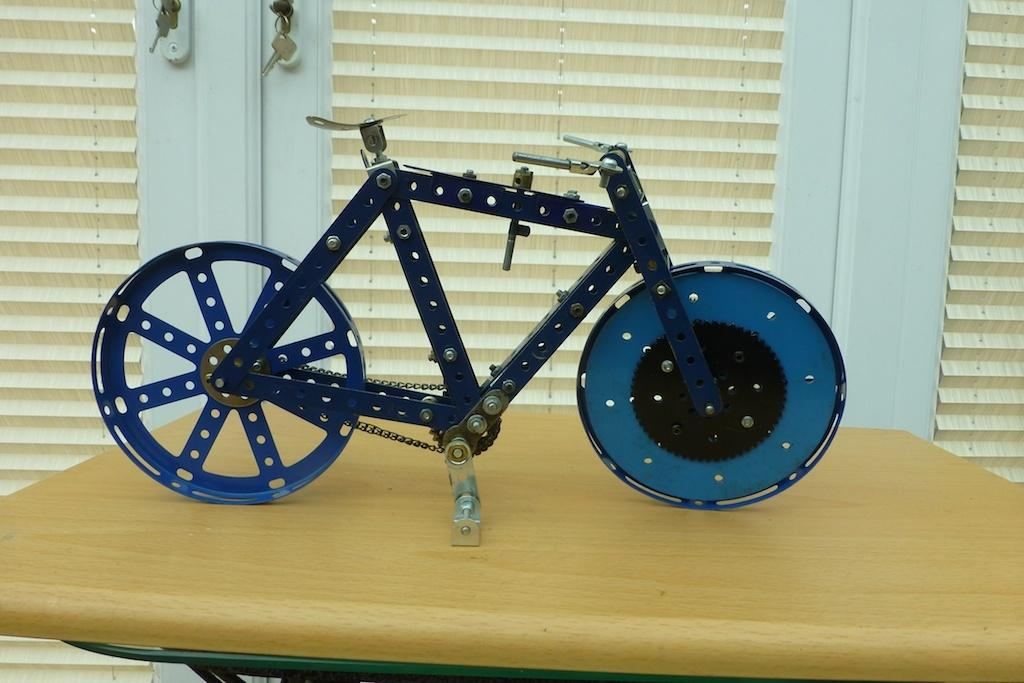What type of toy is in the image? There is a toy bicycle in the image. Where is the toy bicycle located? The toy bicycle is placed on a wooden table. What can be seen in the background of the image? There is a window visible in the background of the image. How many dogs are playing in harmony with the toy bicycle in the image? There are no dogs present in the image, and the concept of harmony with a toy bicycle is not applicable. 